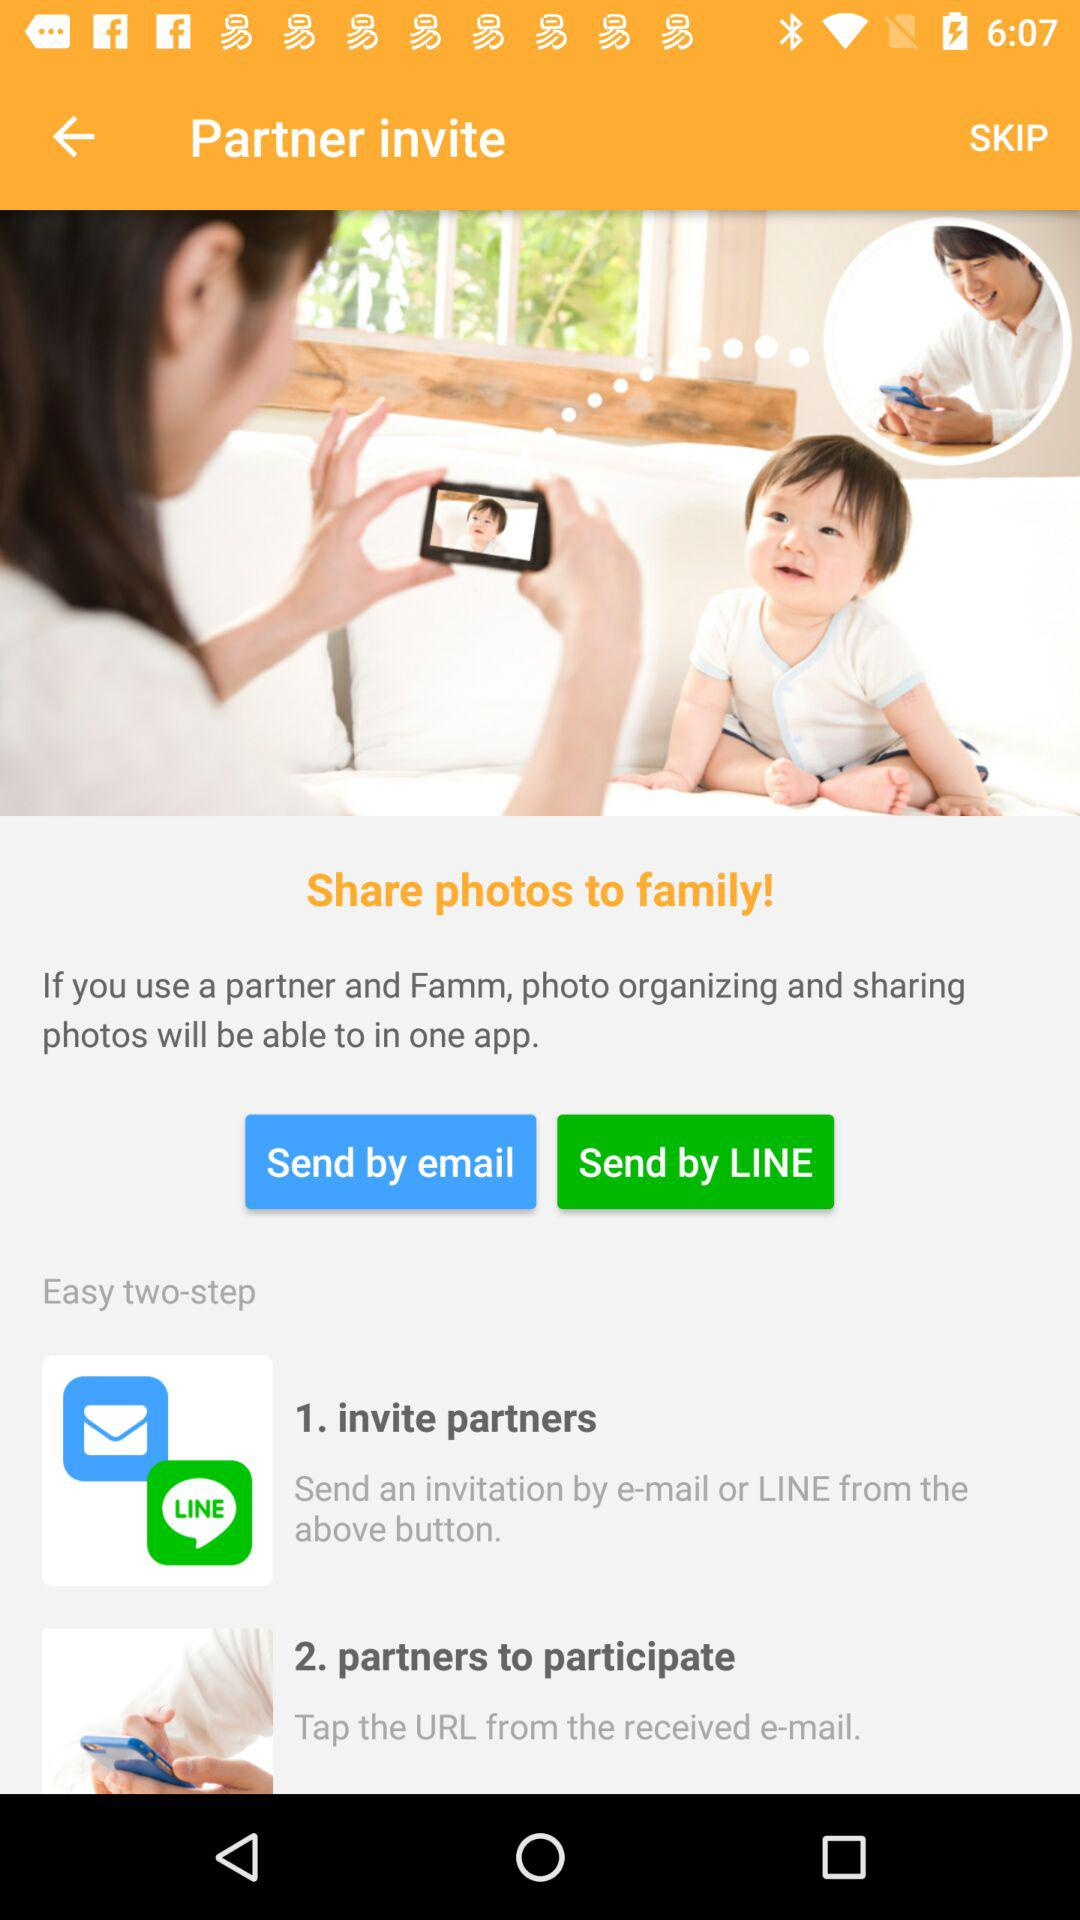Which are the different sharing options? The different sharing options are "email" and "LINE". 